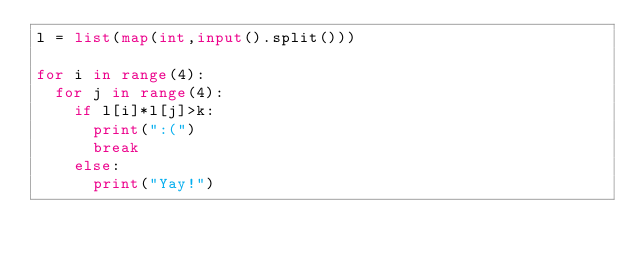<code> <loc_0><loc_0><loc_500><loc_500><_Python_>l = list(map(int,input().split()))

for i in range(4):
  for j in range(4):
    if l[i]*l[j]>k:
      print(":(")
      break
    else:
      print("Yay!")</code> 